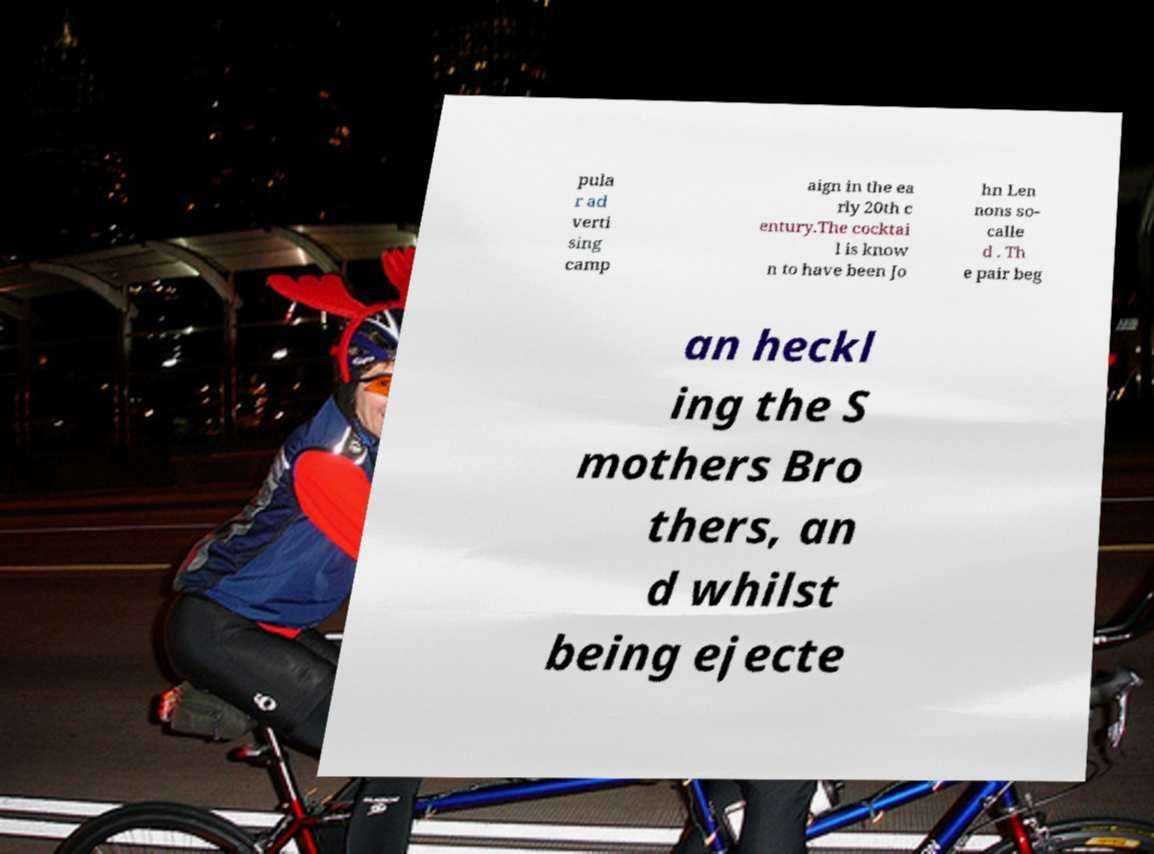Could you assist in decoding the text presented in this image and type it out clearly? pula r ad verti sing camp aign in the ea rly 20th c entury.The cocktai l is know n to have been Jo hn Len nons so- calle d . Th e pair beg an heckl ing the S mothers Bro thers, an d whilst being ejecte 